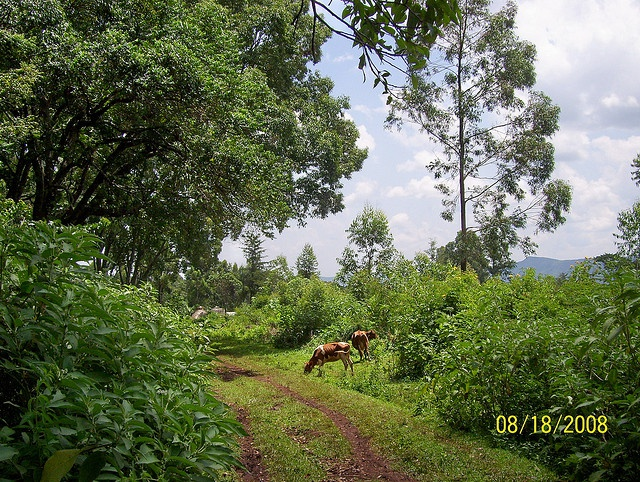Describe the objects in this image and their specific colors. I can see cow in black, olive, maroon, and gray tones and cow in black, olive, maroon, and tan tones in this image. 